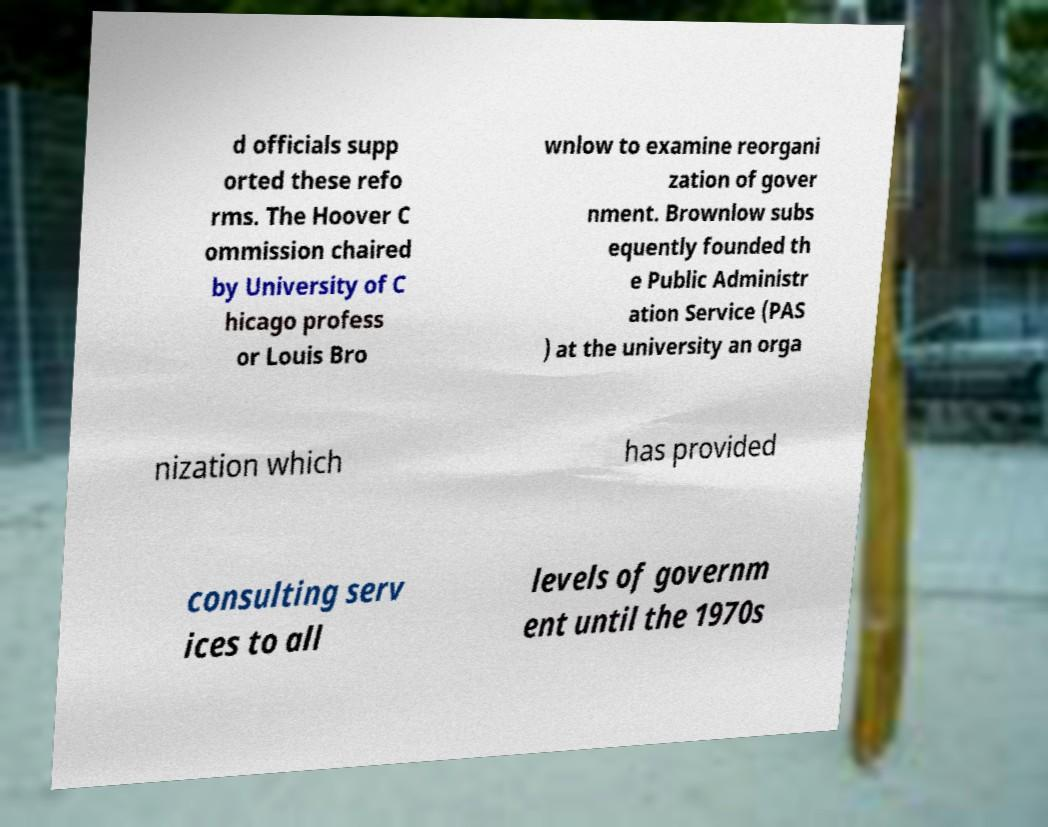Could you assist in decoding the text presented in this image and type it out clearly? d officials supp orted these refo rms. The Hoover C ommission chaired by University of C hicago profess or Louis Bro wnlow to examine reorgani zation of gover nment. Brownlow subs equently founded th e Public Administr ation Service (PAS ) at the university an orga nization which has provided consulting serv ices to all levels of governm ent until the 1970s 